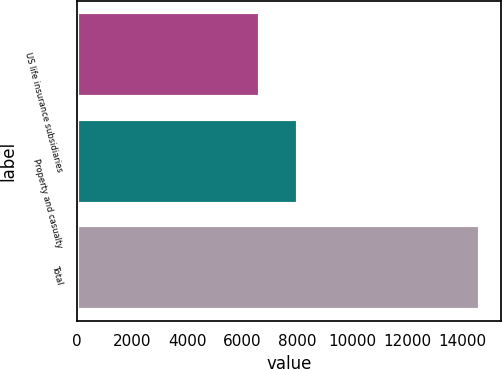<chart> <loc_0><loc_0><loc_500><loc_500><bar_chart><fcel>US life insurance subsidiaries<fcel>Property and casualty<fcel>Total<nl><fcel>6639<fcel>8022<fcel>14661<nl></chart> 